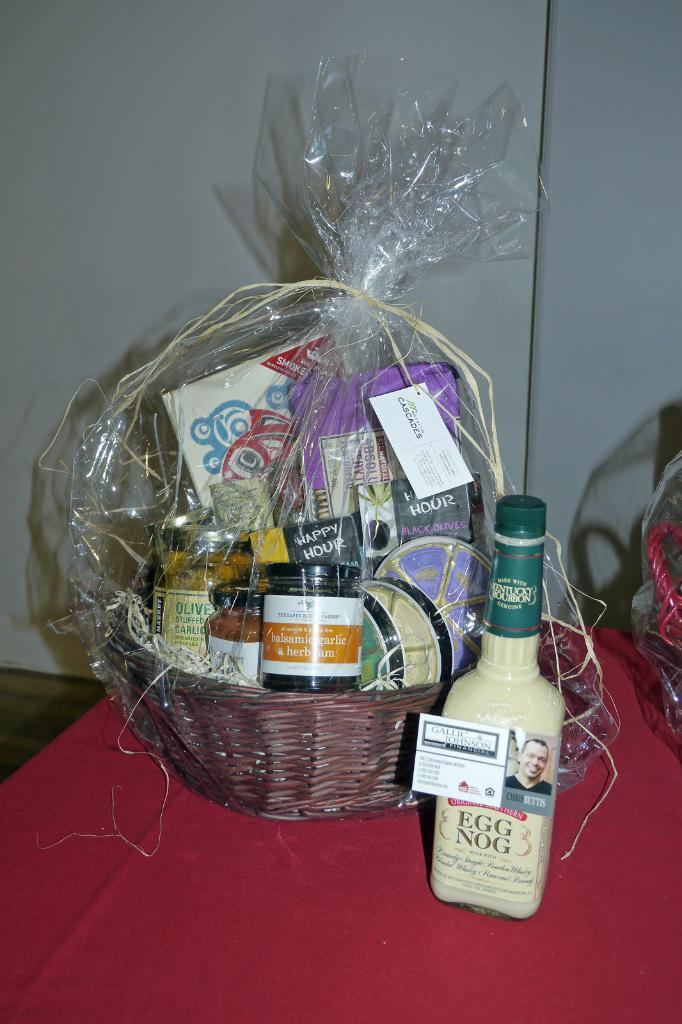<image>
Offer a succinct explanation of the picture presented. The gift basket includes garlic stuffed olives, balsamic garlic and herb jam, Swiss cheese, and Egg Nog. 